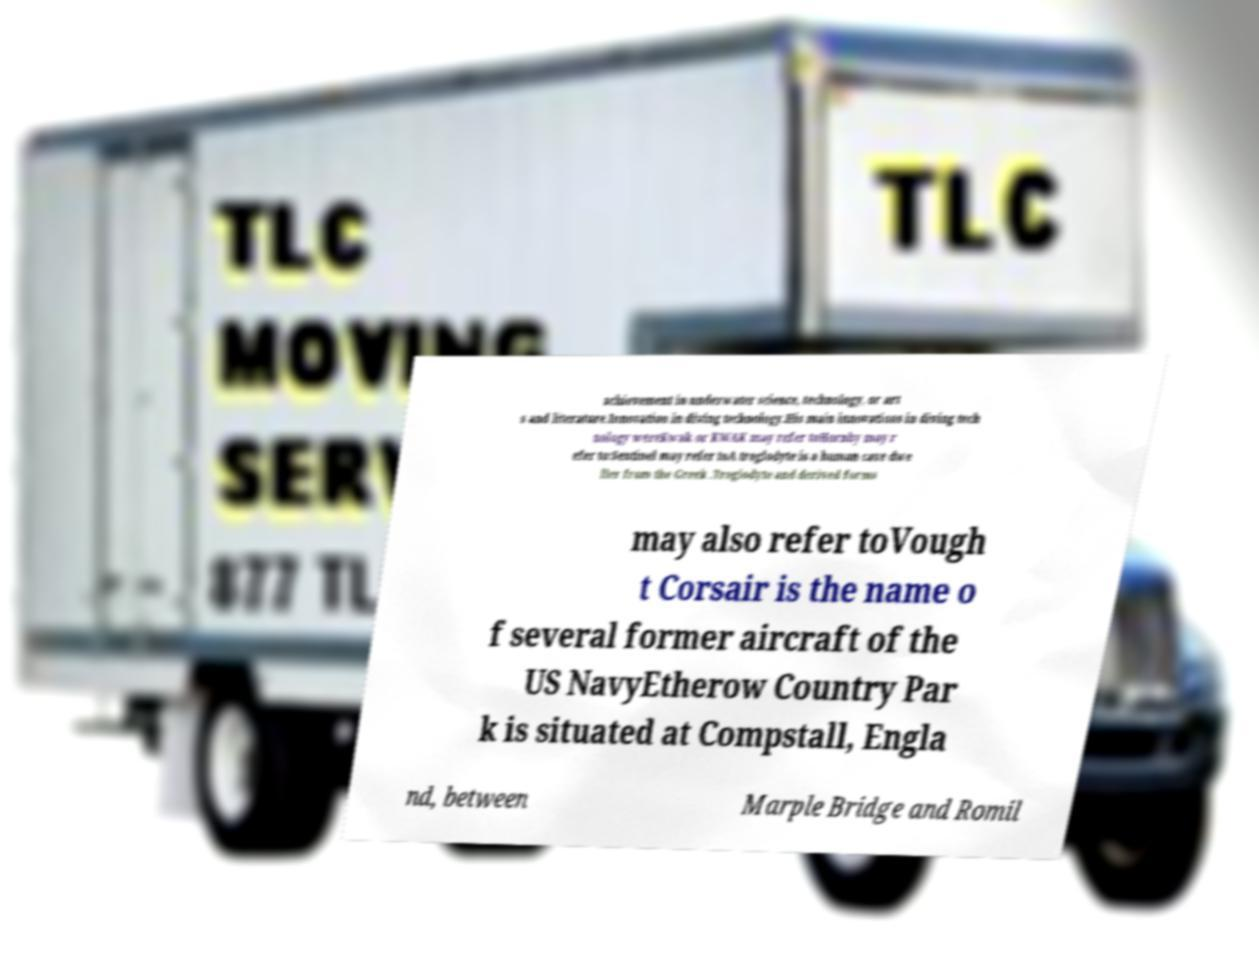Please identify and transcribe the text found in this image. achievement in underwater science, technology, or art s and literature.Innovation in diving technology.His main innovations in diving tech nology wereKwak or KWAK may refer toHornby may r efer to:Sentinel may refer toA troglodyte is a human cave dwe ller from the Greek .Troglodyte and derived forms may also refer toVough t Corsair is the name o f several former aircraft of the US NavyEtherow Country Par k is situated at Compstall, Engla nd, between Marple Bridge and Romil 